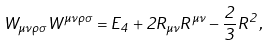<formula> <loc_0><loc_0><loc_500><loc_500>W _ { \mu \nu \rho \sigma } W ^ { \mu \nu \rho \sigma } = E _ { 4 } + 2 R _ { \mu \nu } R ^ { \mu \nu } - \frac { 2 } { 3 } R ^ { 2 } ,</formula> 